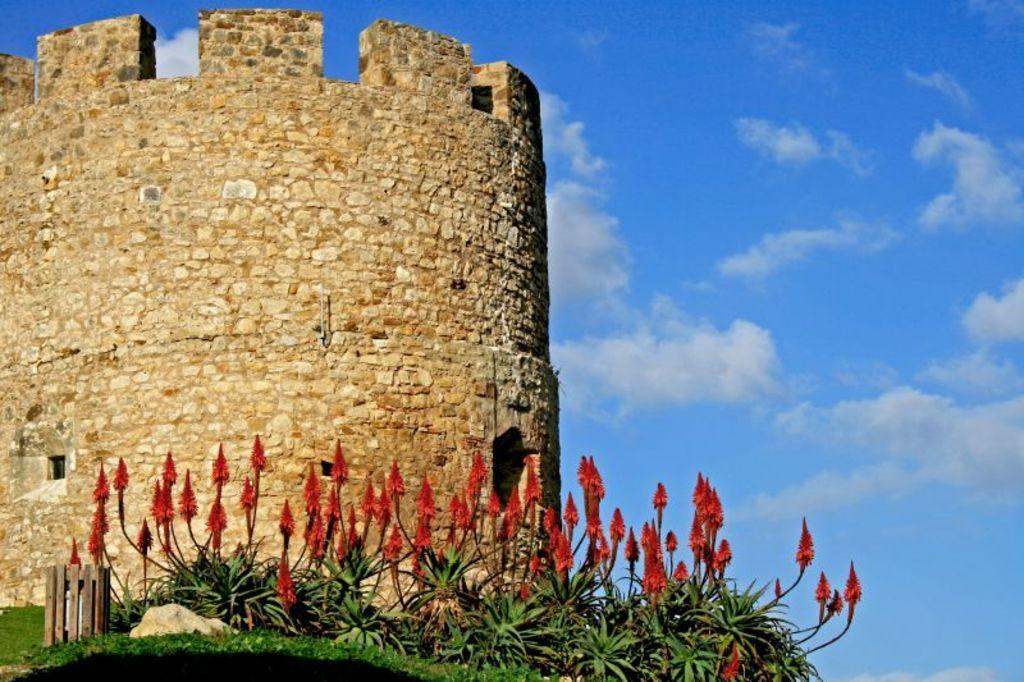What type of vegetation can be seen in the image? There are plants and flowers in the image. What type of ground cover is present in the image? There is grass in the image. What structure is located on the left side of the image? There is a stone wall on the left side of the image. What is visible at the top of the image? The sky is visible at the top of the image. What advertisement can be seen on the stone wall in the image? There is no advertisement present on the stone wall in the image. What type of fact can be learned about the lunchroom from the image? There is no lunchroom present in the image, so no facts about a lunchroom can be learned. 